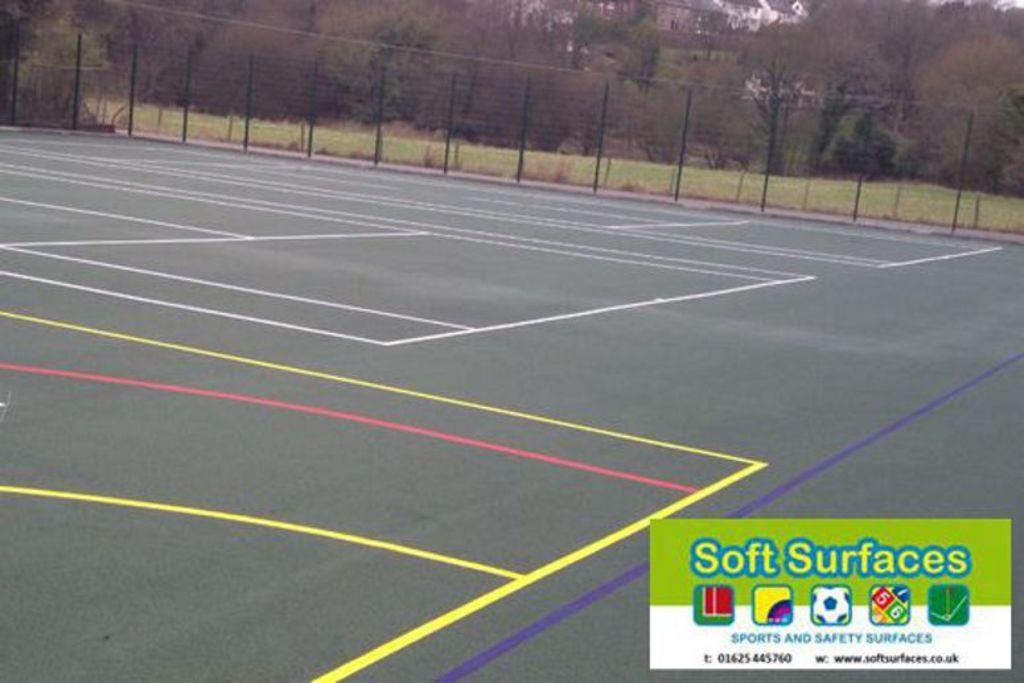How would you summarize this image in a sentence or two? In this image I can see the ground and few lines on the ground why are white, red, yellow and purple in color. In the background I can see he fencing,m few trees which are green and brown in color and few buildings. 